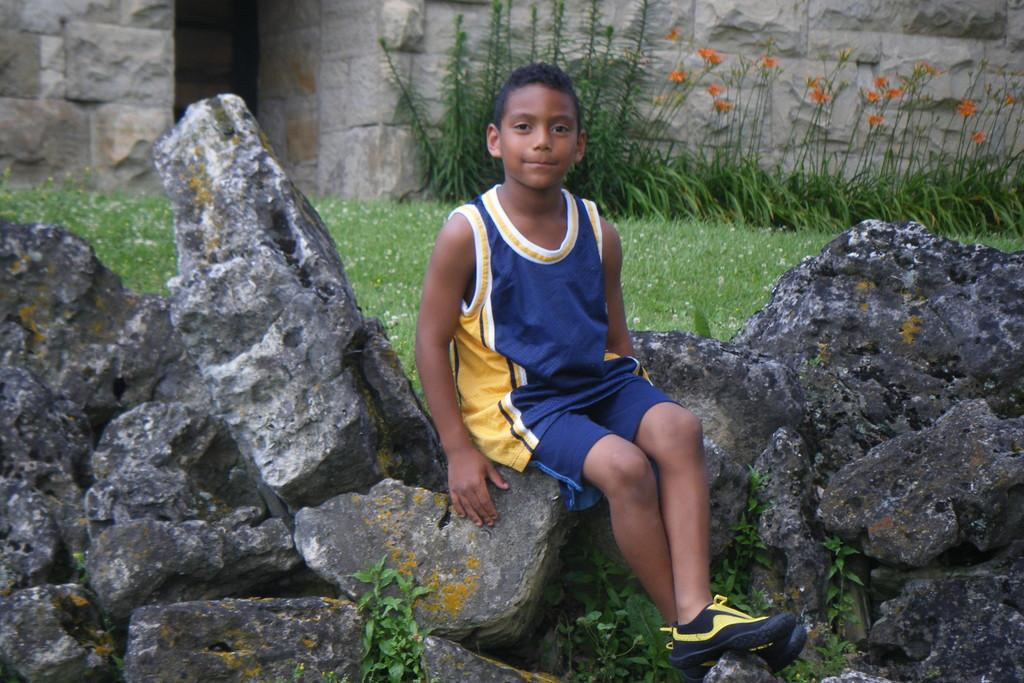Who is the main subject in the image? There is a boy in the image. What is the boy doing in the image? The boy is sitting on rocks. What type of vegetation can be seen in the image? There is grass and plants visible in the image. What is visible in the background of the image? There is a wall in the background of the image. Can you see a snail crawling on the jar in the image? There is no jar or snail present in the image. 